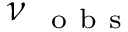<formula> <loc_0><loc_0><loc_500><loc_500>\nu _ { { o b s } }</formula> 